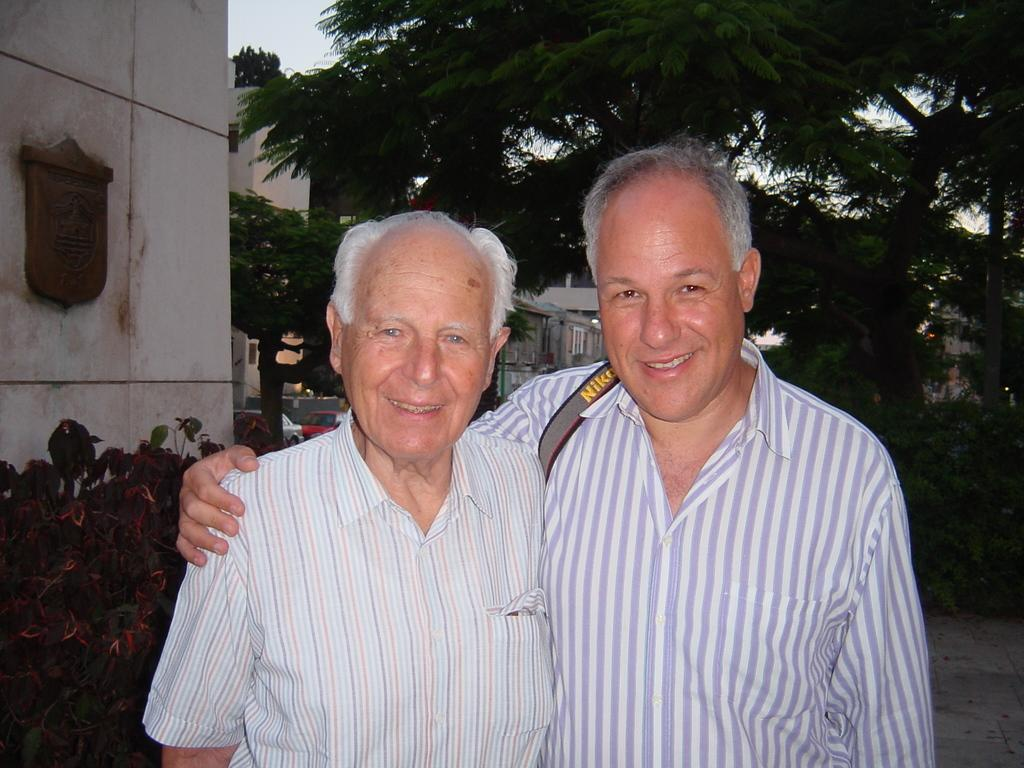<image>
Provide a brief description of the given image. Two older gentlemen stand together in a phone, the man on the right wears a Nikon strap on his right shoulder. 